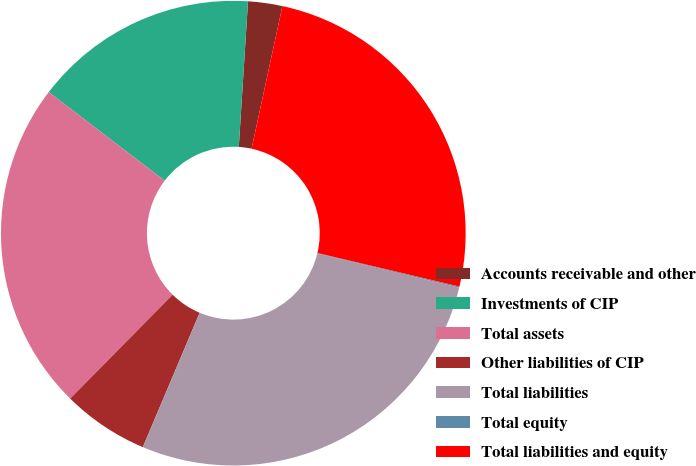Convert chart. <chart><loc_0><loc_0><loc_500><loc_500><pie_chart><fcel>Accounts receivable and other<fcel>Investments of CIP<fcel>Total assets<fcel>Other liabilities of CIP<fcel>Total liabilities<fcel>Total equity<fcel>Total liabilities and equity<nl><fcel>2.38%<fcel>15.62%<fcel>23.0%<fcel>6.02%<fcel>27.6%<fcel>0.08%<fcel>25.3%<nl></chart> 